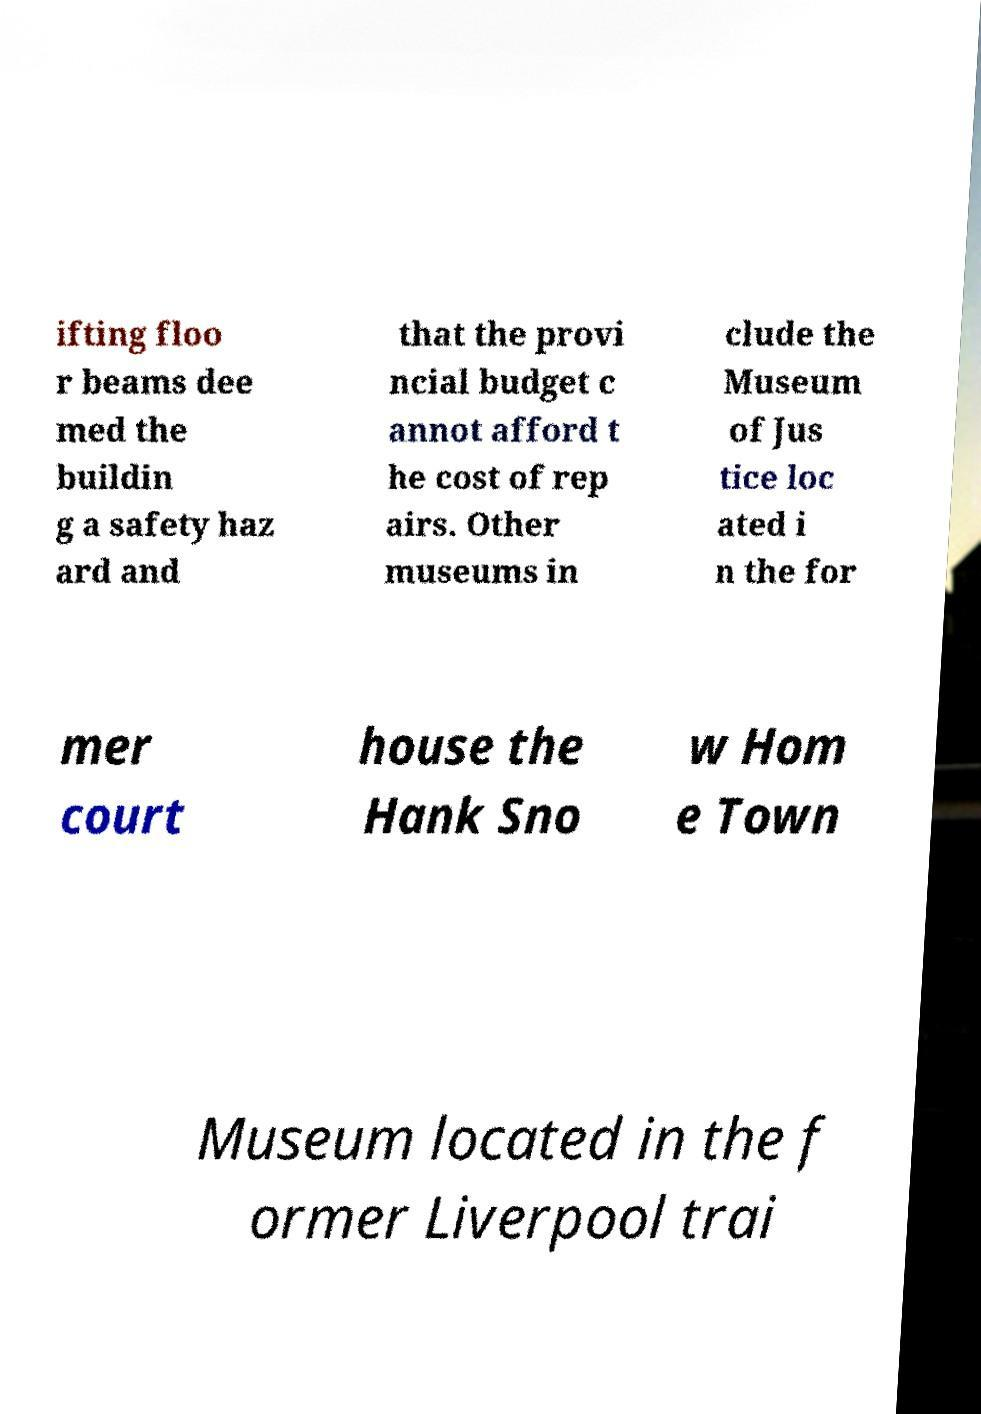Can you accurately transcribe the text from the provided image for me? ifting floo r beams dee med the buildin g a safety haz ard and that the provi ncial budget c annot afford t he cost of rep airs. Other museums in clude the Museum of Jus tice loc ated i n the for mer court house the Hank Sno w Hom e Town Museum located in the f ormer Liverpool trai 